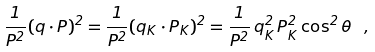<formula> <loc_0><loc_0><loc_500><loc_500>\frac { 1 } { P ^ { 2 } } ( q \cdot P ) ^ { 2 } = \frac { 1 } { P ^ { 2 } } ( q _ { K } \cdot P _ { K } ) ^ { 2 } = \frac { 1 } { P ^ { 2 } } \, { q } _ { K } ^ { 2 } \, { P } _ { K } ^ { 2 } \cos ^ { 2 } { \theta } \ ,</formula> 